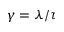Convert formula to latex. <formula><loc_0><loc_0><loc_500><loc_500>\gamma = \lambda / \tau</formula> 